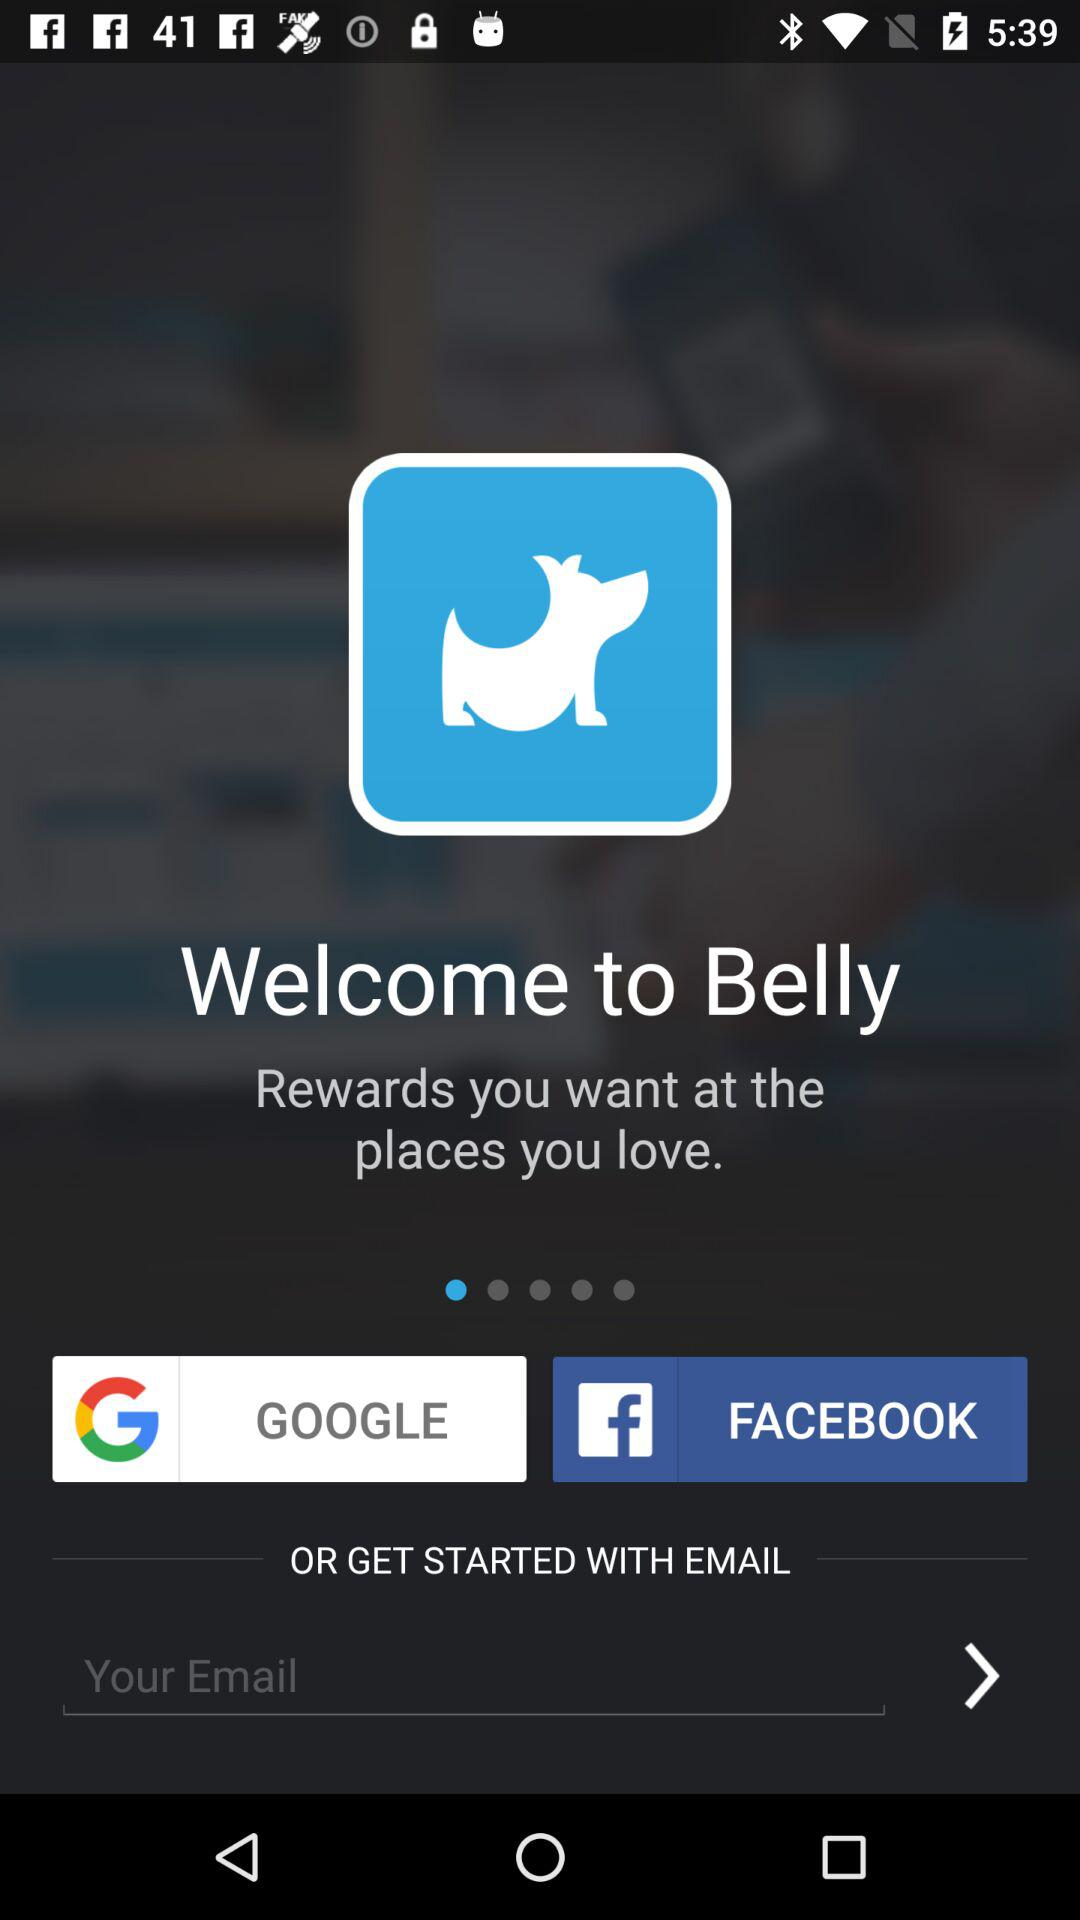What applications can we use to login? You can log in with "GOOGLE", "FACEBOOK" and "EMAIL". 